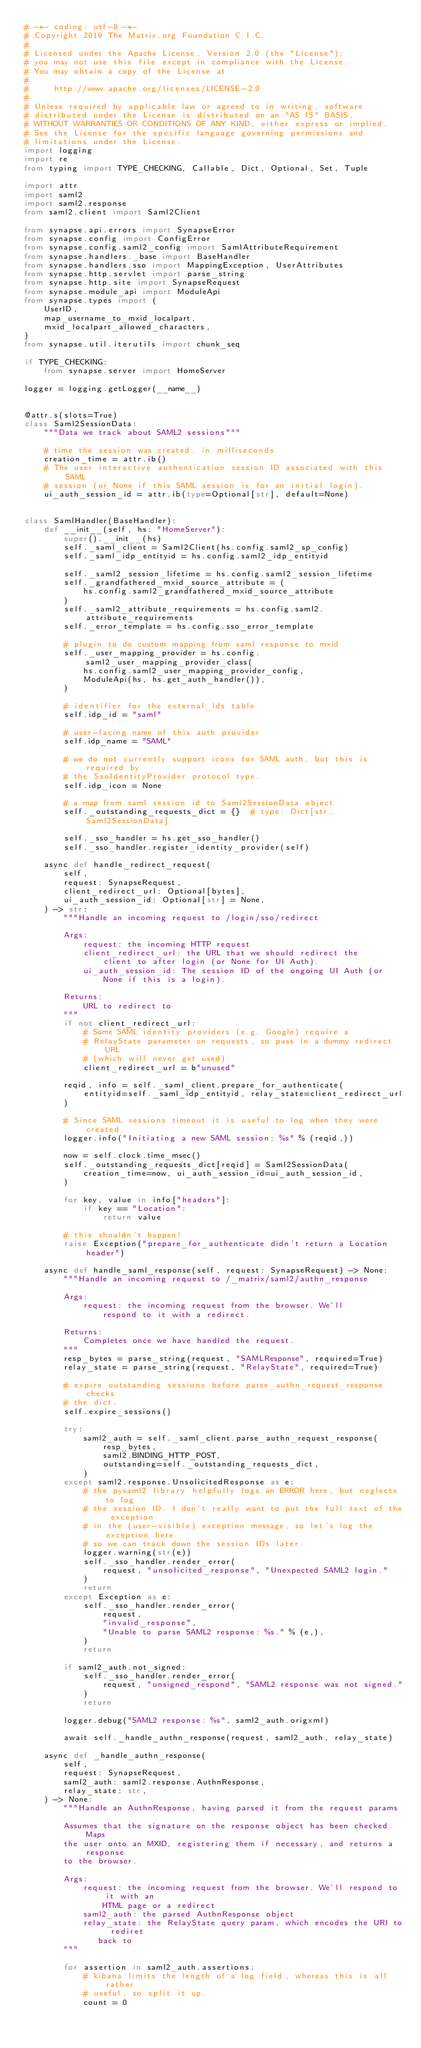<code> <loc_0><loc_0><loc_500><loc_500><_Python_># -*- coding: utf-8 -*-
# Copyright 2019 The Matrix.org Foundation C.I.C.
#
# Licensed under the Apache License, Version 2.0 (the "License");
# you may not use this file except in compliance with the License.
# You may obtain a copy of the License at
#
#     http://www.apache.org/licenses/LICENSE-2.0
#
# Unless required by applicable law or agreed to in writing, software
# distributed under the License is distributed on an "AS IS" BASIS,
# WITHOUT WARRANTIES OR CONDITIONS OF ANY KIND, either express or implied.
# See the License for the specific language governing permissions and
# limitations under the License.
import logging
import re
from typing import TYPE_CHECKING, Callable, Dict, Optional, Set, Tuple

import attr
import saml2
import saml2.response
from saml2.client import Saml2Client

from synapse.api.errors import SynapseError
from synapse.config import ConfigError
from synapse.config.saml2_config import SamlAttributeRequirement
from synapse.handlers._base import BaseHandler
from synapse.handlers.sso import MappingException, UserAttributes
from synapse.http.servlet import parse_string
from synapse.http.site import SynapseRequest
from synapse.module_api import ModuleApi
from synapse.types import (
    UserID,
    map_username_to_mxid_localpart,
    mxid_localpart_allowed_characters,
)
from synapse.util.iterutils import chunk_seq

if TYPE_CHECKING:
    from synapse.server import HomeServer

logger = logging.getLogger(__name__)


@attr.s(slots=True)
class Saml2SessionData:
    """Data we track about SAML2 sessions"""

    # time the session was created, in milliseconds
    creation_time = attr.ib()
    # The user interactive authentication session ID associated with this SAML
    # session (or None if this SAML session is for an initial login).
    ui_auth_session_id = attr.ib(type=Optional[str], default=None)


class SamlHandler(BaseHandler):
    def __init__(self, hs: "HomeServer"):
        super().__init__(hs)
        self._saml_client = Saml2Client(hs.config.saml2_sp_config)
        self._saml_idp_entityid = hs.config.saml2_idp_entityid

        self._saml2_session_lifetime = hs.config.saml2_session_lifetime
        self._grandfathered_mxid_source_attribute = (
            hs.config.saml2_grandfathered_mxid_source_attribute
        )
        self._saml2_attribute_requirements = hs.config.saml2.attribute_requirements
        self._error_template = hs.config.sso_error_template

        # plugin to do custom mapping from saml response to mxid
        self._user_mapping_provider = hs.config.saml2_user_mapping_provider_class(
            hs.config.saml2_user_mapping_provider_config,
            ModuleApi(hs, hs.get_auth_handler()),
        )

        # identifier for the external_ids table
        self.idp_id = "saml"

        # user-facing name of this auth provider
        self.idp_name = "SAML"

        # we do not currently support icons for SAML auth, but this is required by
        # the SsoIdentityProvider protocol type.
        self.idp_icon = None

        # a map from saml session id to Saml2SessionData object
        self._outstanding_requests_dict = {}  # type: Dict[str, Saml2SessionData]

        self._sso_handler = hs.get_sso_handler()
        self._sso_handler.register_identity_provider(self)

    async def handle_redirect_request(
        self,
        request: SynapseRequest,
        client_redirect_url: Optional[bytes],
        ui_auth_session_id: Optional[str] = None,
    ) -> str:
        """Handle an incoming request to /login/sso/redirect

        Args:
            request: the incoming HTTP request
            client_redirect_url: the URL that we should redirect the
                client to after login (or None for UI Auth).
            ui_auth_session_id: The session ID of the ongoing UI Auth (or
                None if this is a login).

        Returns:
            URL to redirect to
        """
        if not client_redirect_url:
            # Some SAML identity providers (e.g. Google) require a
            # RelayState parameter on requests, so pass in a dummy redirect URL
            # (which will never get used).
            client_redirect_url = b"unused"

        reqid, info = self._saml_client.prepare_for_authenticate(
            entityid=self._saml_idp_entityid, relay_state=client_redirect_url
        )

        # Since SAML sessions timeout it is useful to log when they were created.
        logger.info("Initiating a new SAML session: %s" % (reqid,))

        now = self.clock.time_msec()
        self._outstanding_requests_dict[reqid] = Saml2SessionData(
            creation_time=now, ui_auth_session_id=ui_auth_session_id,
        )

        for key, value in info["headers"]:
            if key == "Location":
                return value

        # this shouldn't happen!
        raise Exception("prepare_for_authenticate didn't return a Location header")

    async def handle_saml_response(self, request: SynapseRequest) -> None:
        """Handle an incoming request to /_matrix/saml2/authn_response

        Args:
            request: the incoming request from the browser. We'll
                respond to it with a redirect.

        Returns:
            Completes once we have handled the request.
        """
        resp_bytes = parse_string(request, "SAMLResponse", required=True)
        relay_state = parse_string(request, "RelayState", required=True)

        # expire outstanding sessions before parse_authn_request_response checks
        # the dict.
        self.expire_sessions()

        try:
            saml2_auth = self._saml_client.parse_authn_request_response(
                resp_bytes,
                saml2.BINDING_HTTP_POST,
                outstanding=self._outstanding_requests_dict,
            )
        except saml2.response.UnsolicitedResponse as e:
            # the pysaml2 library helpfully logs an ERROR here, but neglects to log
            # the session ID. I don't really want to put the full text of the exception
            # in the (user-visible) exception message, so let's log the exception here
            # so we can track down the session IDs later.
            logger.warning(str(e))
            self._sso_handler.render_error(
                request, "unsolicited_response", "Unexpected SAML2 login."
            )
            return
        except Exception as e:
            self._sso_handler.render_error(
                request,
                "invalid_response",
                "Unable to parse SAML2 response: %s." % (e,),
            )
            return

        if saml2_auth.not_signed:
            self._sso_handler.render_error(
                request, "unsigned_respond", "SAML2 response was not signed."
            )
            return

        logger.debug("SAML2 response: %s", saml2_auth.origxml)

        await self._handle_authn_response(request, saml2_auth, relay_state)

    async def _handle_authn_response(
        self,
        request: SynapseRequest,
        saml2_auth: saml2.response.AuthnResponse,
        relay_state: str,
    ) -> None:
        """Handle an AuthnResponse, having parsed it from the request params

        Assumes that the signature on the response object has been checked. Maps
        the user onto an MXID, registering them if necessary, and returns a response
        to the browser.

        Args:
            request: the incoming request from the browser. We'll respond to it with an
                HTML page or a redirect
            saml2_auth: the parsed AuthnResponse object
            relay_state: the RelayState query param, which encodes the URI to rediret
               back to
        """

        for assertion in saml2_auth.assertions:
            # kibana limits the length of a log field, whereas this is all rather
            # useful, so split it up.
            count = 0</code> 